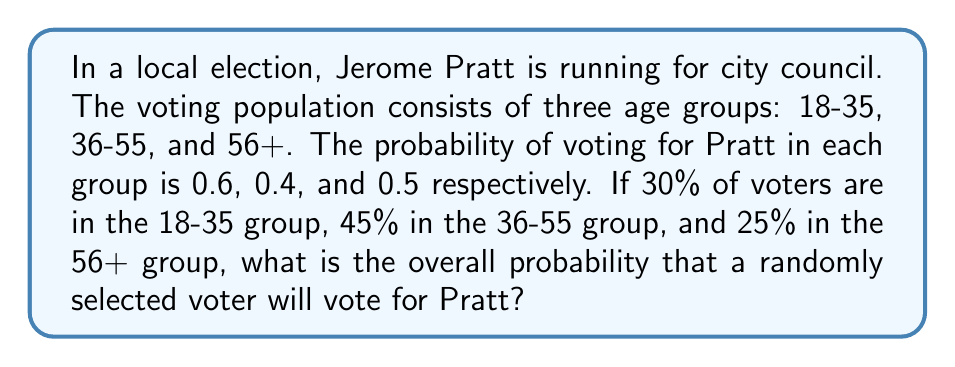Teach me how to tackle this problem. Let's approach this step-by-step:

1) We need to use the law of total probability. The formula is:

   $P(A) = \sum_{i=1}^n P(A|B_i) \cdot P(B_i)$

   where $A$ is the event of voting for Pratt, and $B_i$ are the different age groups.

2) We have:
   - $P(\text{Vote for Pratt} | 18\text{-}35) = 0.6$
   - $P(\text{Vote for Pratt} | 36\text{-}55) = 0.4$
   - $P(\text{Vote for Pratt} | 56+) = 0.5$

   - $P(18\text{-}35) = 0.30$
   - $P(36\text{-}55) = 0.45$
   - $P(56+) = 0.25$

3) Now, let's apply the formula:

   $$\begin{align*}
   P(\text{Vote for Pratt}) &= P(\text{Vote for Pratt} | 18\text{-}35) \cdot P(18\text{-}35) \\
   &+ P(\text{Vote for Pratt} | 36\text{-}55) \cdot P(36\text{-}55) \\
   &+ P(\text{Vote for Pratt} | 56+) \cdot P(56+)
   \end{align*}$$

4) Substituting the values:

   $$\begin{align*}
   P(\text{Vote for Pratt}) &= 0.6 \cdot 0.30 + 0.4 \cdot 0.45 + 0.5 \cdot 0.25 \\
   &= 0.18 + 0.18 + 0.125 \\
   &= 0.485
   \end{align*}$$

5) Therefore, the probability that a randomly selected voter will vote for Pratt is 0.485 or 48.5%.
Answer: 0.485 